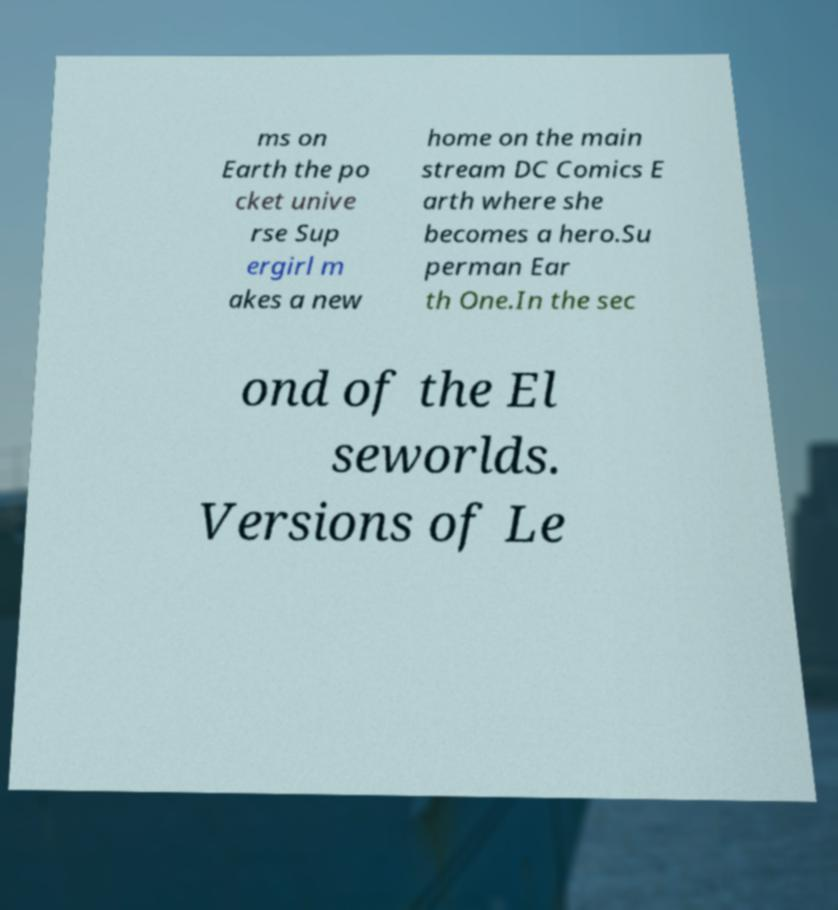What messages or text are displayed in this image? I need them in a readable, typed format. ms on Earth the po cket unive rse Sup ergirl m akes a new home on the main stream DC Comics E arth where she becomes a hero.Su perman Ear th One.In the sec ond of the El seworlds. Versions of Le 